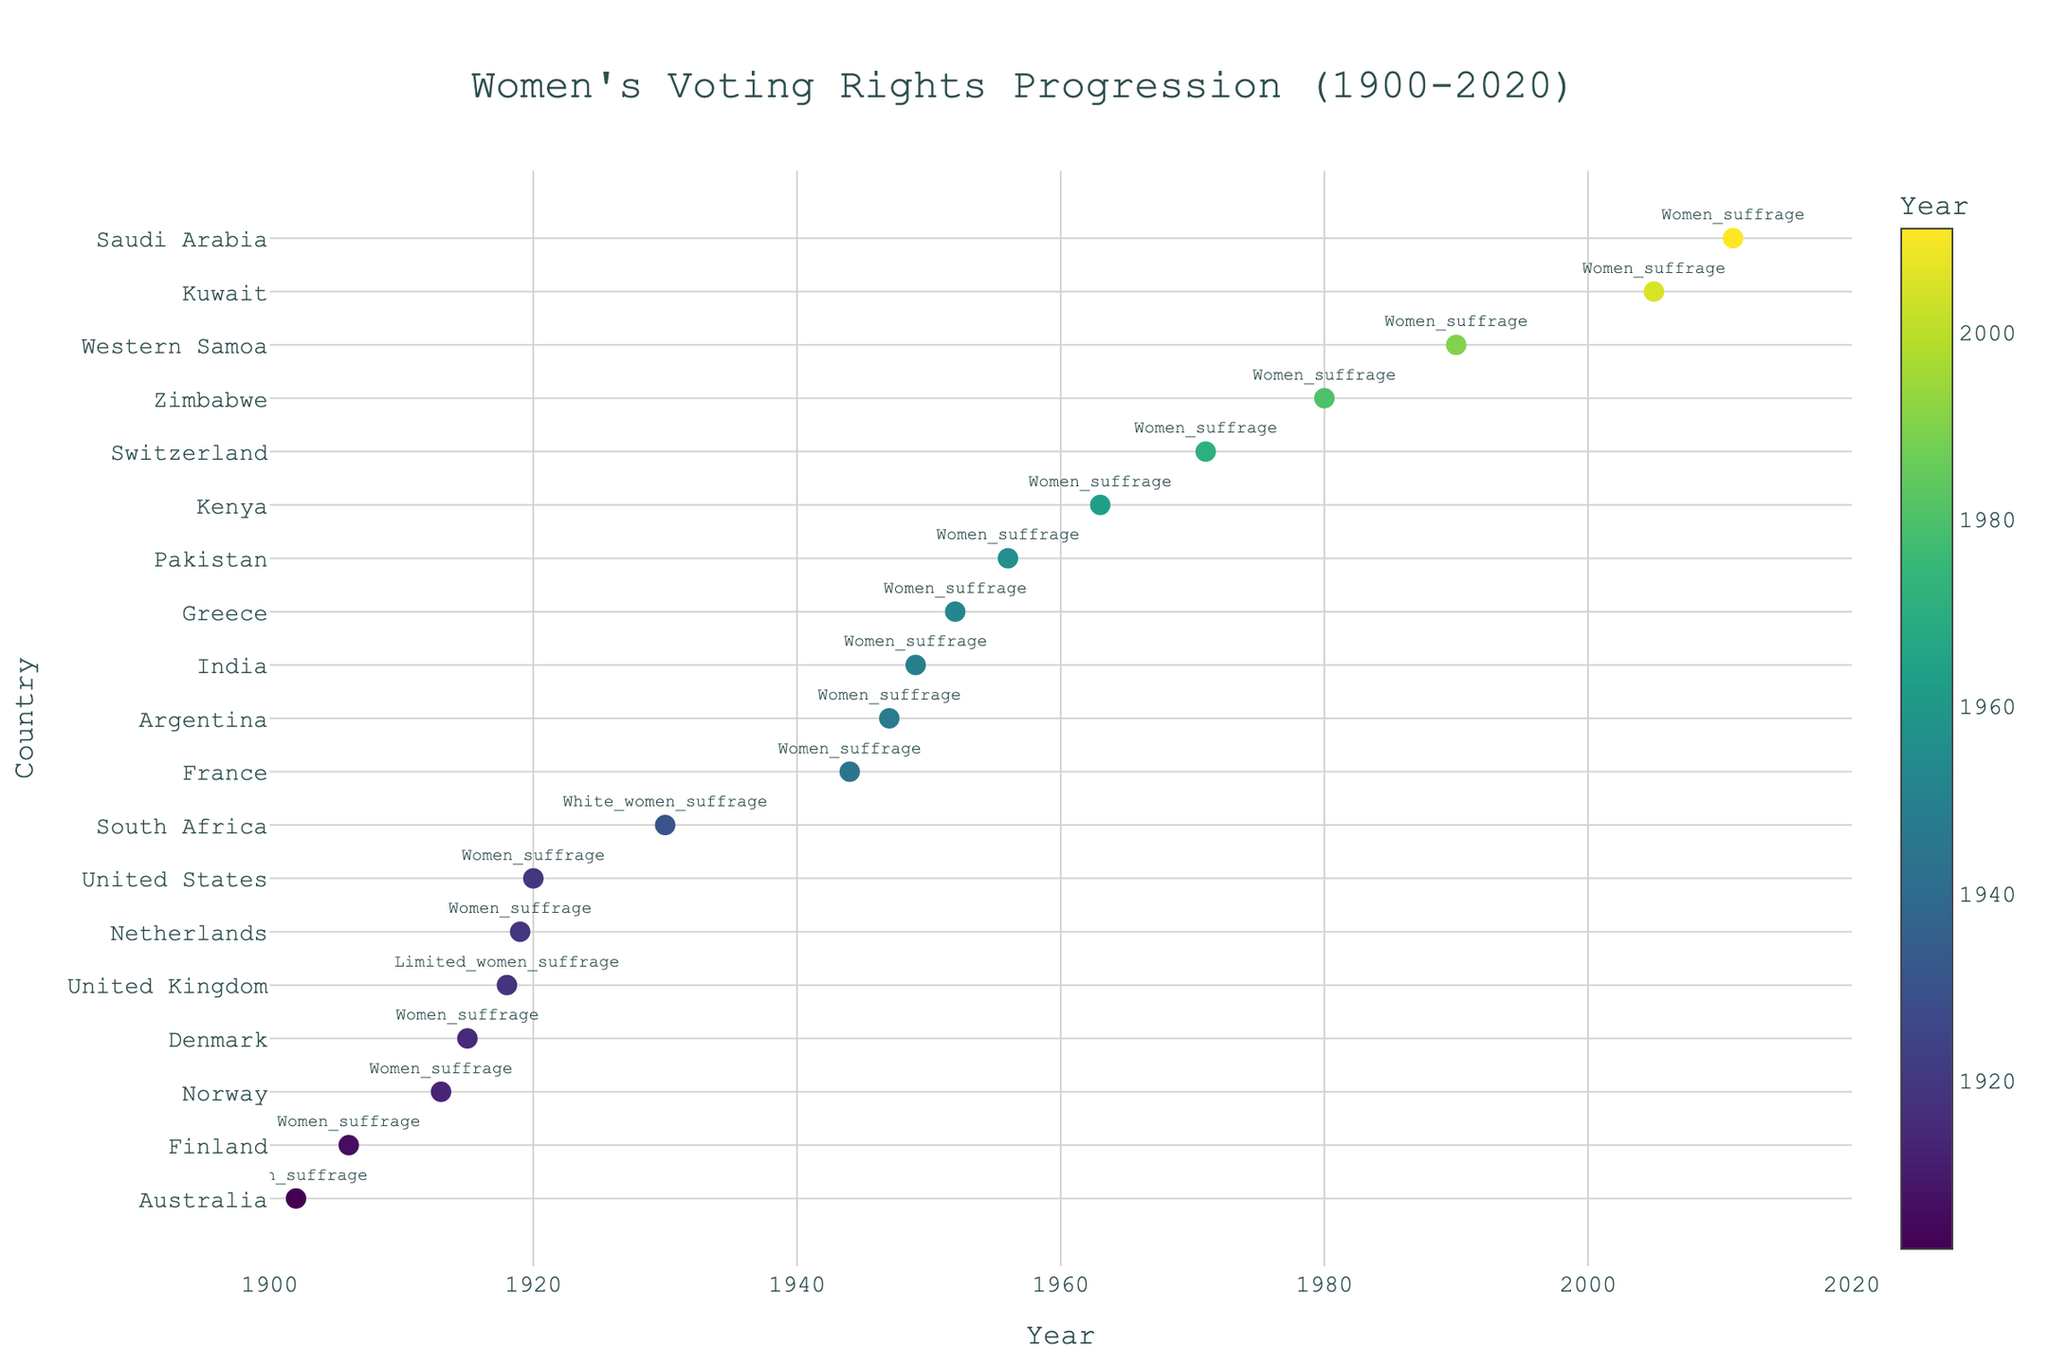Which country is the latest to grant women's voting rights according to the figure? The figure shows Saudi Arabia as the country granting women's voting rights in the latest year, 2011.
Answer: Saudi Arabia Who granted women the right to vote in 1918? Looking at the year 1918 on the x-axis, we see "United Kingdom" listed.
Answer: United Kingdom Between 1900 and 1950, which country was the first to grant women voting rights? Referring to the data points on the figure between 1900 and 1950, the first data point shown is Australia in 1902.
Answer: Australia How many years were there between women obtaining suffrage in Pakistan and Kenya? Pakistan granted women suffrage in 1956 and Kenya in 1963. The difference is 1963 - 1956 = 7 years.
Answer: 7 years Which two countries granted women's suffrage closest to each other in time? Observing the years on the x-axis, the Netherlands (1919) and the United States (1920) granted women's suffrage only 1 year apart.
Answer: Netherlands and United States What year is associated with white women's suffrage in South Africa according to the figure? The figure shows "White women suffrage" listed for South Africa in 1930.
Answer: 1930 What is the median year of women's suffrage being granted based on the data points? Sorting all the years in the figure, the median value (the middle value of the sorted list) is the year 1947.
Answer: 1947 How many countries granted women the right to vote between 1940 and 1950? The figure shows France (1944), Argentina (1947), and India (1949) granting women's suffrage, totaling three countries in that decade.
Answer: 3 countries Compare the year women's suffrage was granted in France to that of Argentina. Which one was earlier? According to the data points on the figure, France granted women's suffrage in 1944, and Argentina did so in 1947. 1944 is earlier than 1947.
Answer: France Which country is represented with the highest x-axis value for the year women's suffrage was granted? The highest year value on the x-axis is 2011, which corresponds to Saudi Arabia.
Answer: Saudi Arabia 